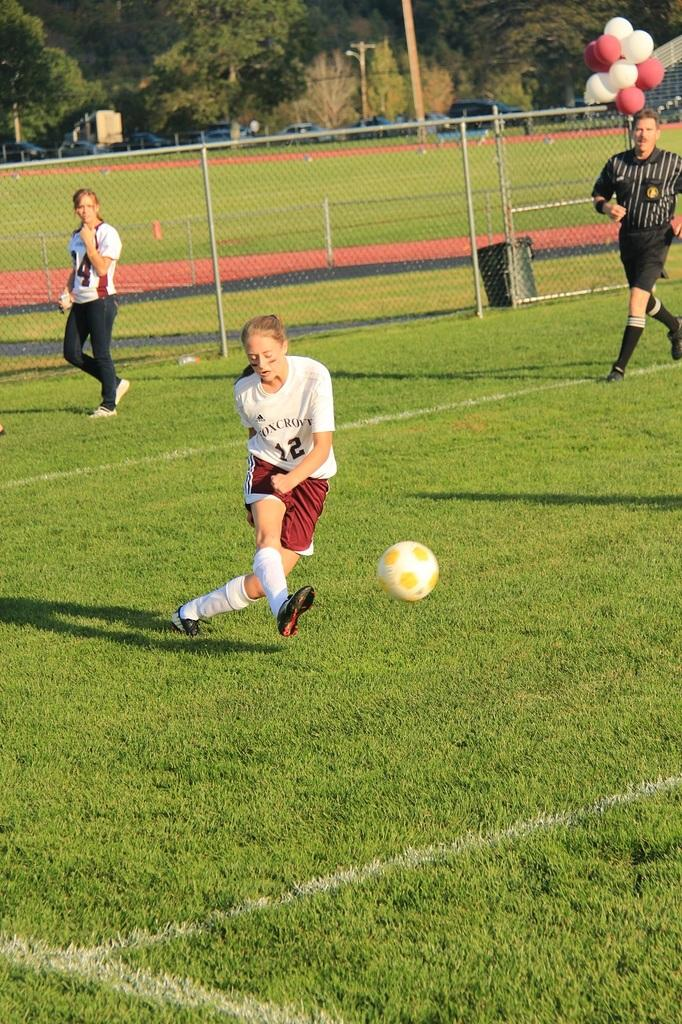Provide a one-sentence caption for the provided image. A female soccer player with the number 12 on the front of her shirt, is about to kick the soccer ball across the field. 